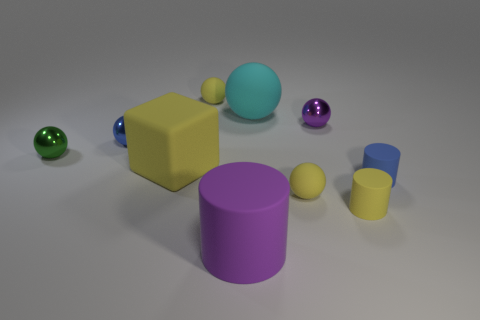What number of tiny green balls have the same material as the big purple cylinder?
Offer a very short reply. 0. The rubber cube has what color?
Your answer should be very brief. Yellow. Does the purple thing in front of the blue rubber thing have the same shape as the thing that is right of the tiny yellow cylinder?
Make the answer very short. Yes. There is a large object that is behind the green shiny object; what color is it?
Your answer should be very brief. Cyan. Are there fewer small things left of the yellow rubber block than rubber cylinders that are behind the large rubber cylinder?
Provide a succinct answer. No. How many other things are made of the same material as the big yellow block?
Ensure brevity in your answer.  6. Is the material of the cyan ball the same as the large purple object?
Offer a terse response. Yes. What number of other things are there of the same size as the cube?
Your answer should be very brief. 2. What is the size of the blue thing right of the large thing in front of the cube?
Offer a very short reply. Small. What color is the small metallic ball to the right of the small yellow sphere that is on the left side of the tiny matte sphere that is in front of the big cyan ball?
Offer a very short reply. Purple. 